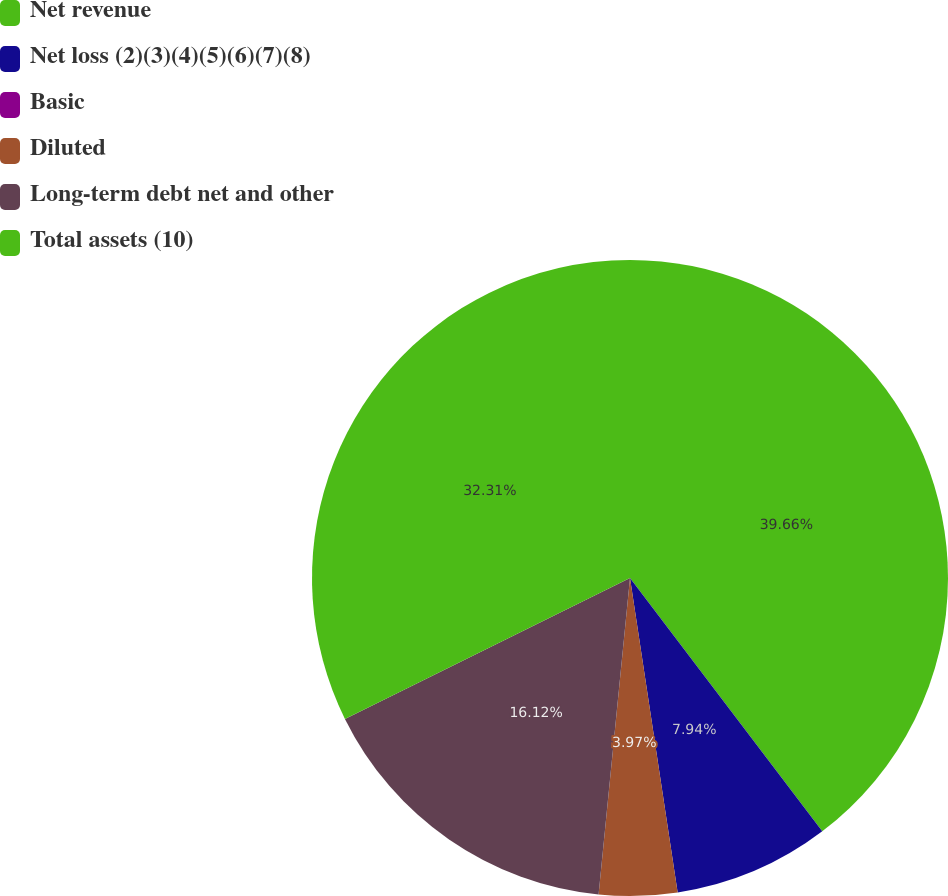Convert chart to OTSL. <chart><loc_0><loc_0><loc_500><loc_500><pie_chart><fcel>Net revenue<fcel>Net loss (2)(3)(4)(5)(6)(7)(8)<fcel>Basic<fcel>Diluted<fcel>Long-term debt net and other<fcel>Total assets (10)<nl><fcel>39.67%<fcel>7.94%<fcel>0.0%<fcel>3.97%<fcel>16.12%<fcel>32.31%<nl></chart> 